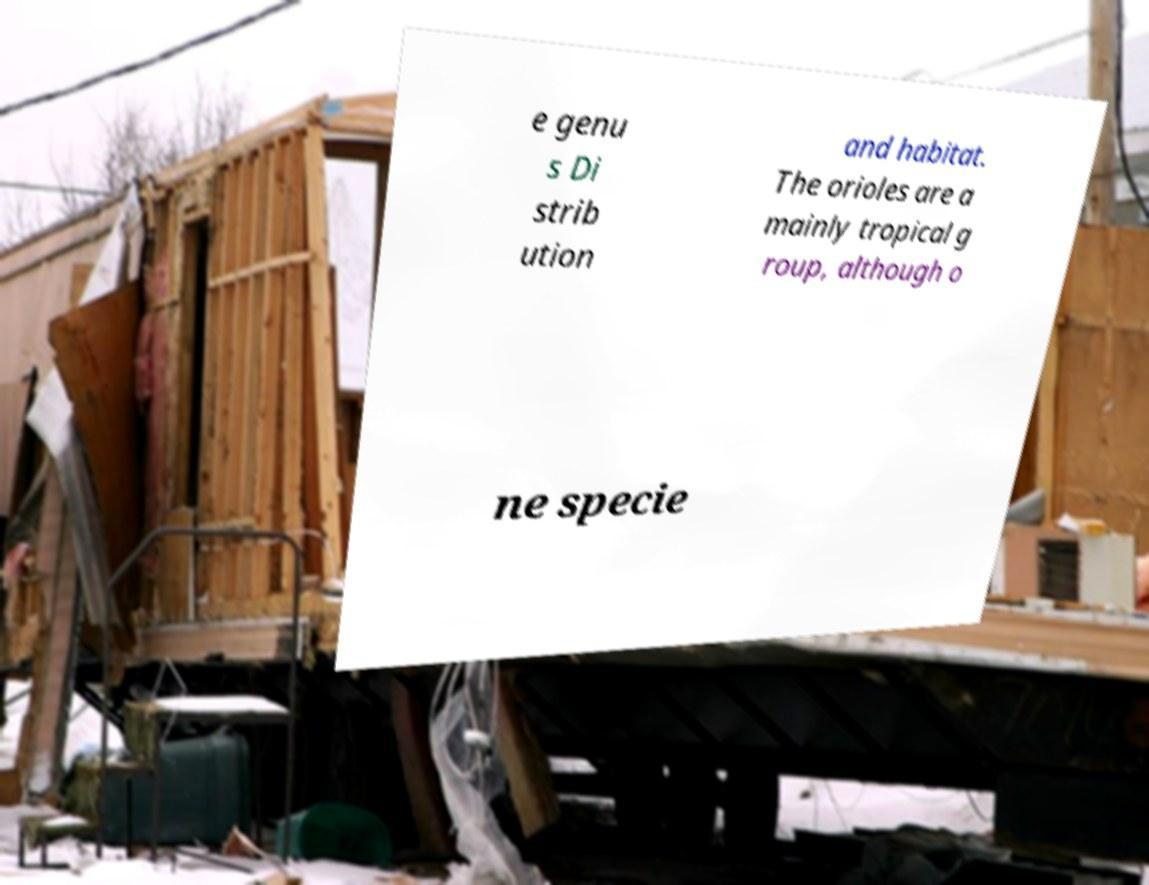Please identify and transcribe the text found in this image. e genu s Di strib ution and habitat. The orioles are a mainly tropical g roup, although o ne specie 